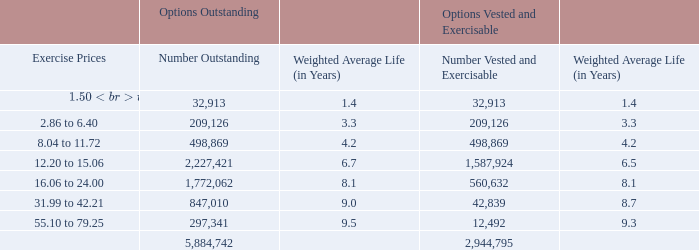A summary of options outstanding and vested as of December 31, 2019 is as follows:
The total intrinsic value of options exercised during 2019, 2018, and 2017 was $318.5 million, $17.4 million, and $6.6 million, respectively.
The weighted average grant date fair value of options granted during the years ended December 31, 2019, 2018, and 2017, was $19.80, $9.07, and $6.44 per share, respectively. During the year ended December 31, 2019, 2,141,078 options vested. There were 2,939,947 options unvested as of December 31, 2019.
As of December 31, 2019, $30.3 million of total unrecognized compensation cost related to stock options was expected to be recognized over a weighted average period of approximately 2.5 years.
What are the total respective values of options exercised during 2019, 2018 and 2017 respectively? $318.5 million, $17.4 million, $6.6 million. What are the weighted average grant date fair value of options granted during the years ended December 31, 2019, 2018, and 2017 respectively? $19.80, $9.07, $6.44. As of December 31, 2019, what is the value of the total unrecognized compensation cost related to stock options was expected to be recognized? $30.3 million. What is the number of outstanding options whose exercise price are between $1.50 to $6.40? 32,913 + 209,126 
Answer: 242039. What would be the number of outstanding options whose exercise price are between $8.04 to $15.06? 498,869 + 2,227,421 
Answer: 2726290. What is the number of outstanding options with an exercise price of between 12.20 to 15.06 as a percentage of the total number of outstanding options?
Answer scale should be: percent. 2,227,421/5,884,742 
Answer: 37.85. 